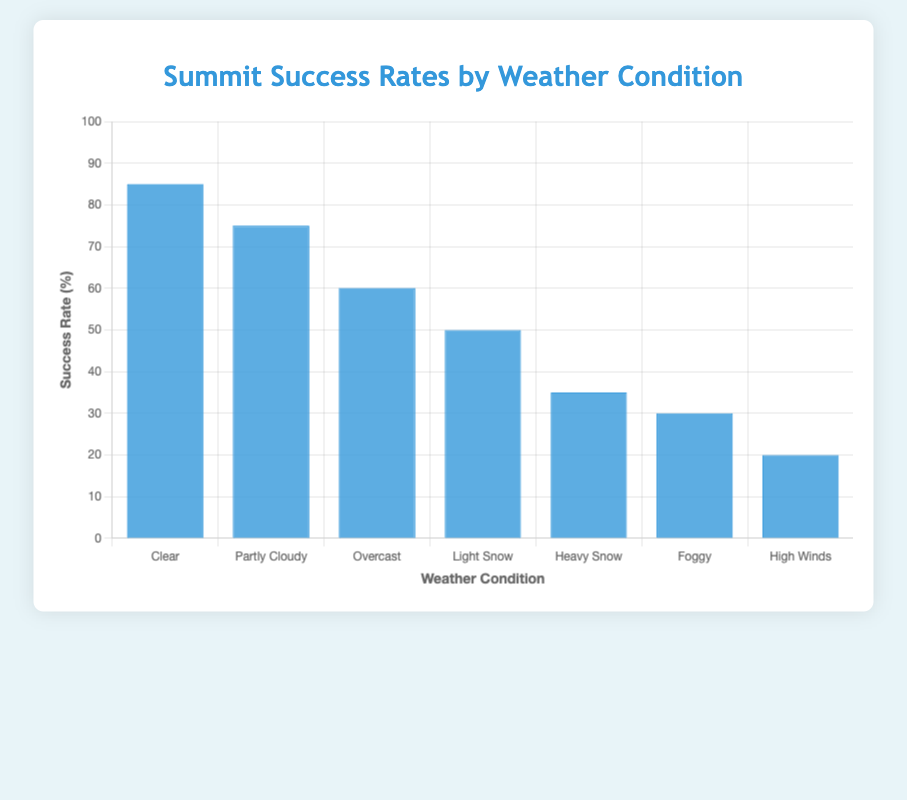What weather condition has the highest summit success rate? The bar for "Clear" weather condition is the tallest, indicating the highest success rate compared to the other weather conditions.
Answer: Clear Which weather condition has a summit success rate higher than "Light Snow" and lower than "Clear"? The "Partly Cloudy" weather condition has a higher success rate than "Light Snow" but lower than "Clear," with success rates of 75% and 50% respectively.
Answer: Partly Cloudy Compare the summit success rates between "Heavy Snow" and "Foggy." Which is higher? The bar for "Heavy Snow" is slightly higher than the bar for "Foggy," indicating that "Heavy Snow" has a higher success rate. "Heavy Snow" is 35% and "Foggy" is 30%.
Answer: Heavy Snow What is the combined success rate for "Clear" and "Partly Cloudy" weather conditions? Summing the success rates of "Clear" (85%) and "Partly Cloudy" (75%) results in 85 + 75 = 160.
Answer: 160 Find the difference in success rate between "High Winds" and "Partly Cloudy." The success rate for "Partly Cloudy" is 75%, and for "High Winds" it is 20%. The difference is 75 - 20 = 55.
Answer: 55 Which weather condition has the smallest success rate, and what is it? The shortest bar represents the "High Winds" weather condition, indicating it has the smallest success rate.
Answer: High Winds Arrange the weather conditions in descending order of summit success rates. The order from the tallest to the shortest bars is: Clear, Partly Cloudy, Overcast, Light Snow, Heavy Snow, Foggy, High Winds.
Answer: Clear, Partly Cloudy, Overcast, Light Snow, Heavy Snow, Foggy, High Winds What is the average success rate of all summit attempts? Summing all the success rates: 85 + 75 + 60 + 50 + 35 + 30 + 20 = 355. Dividing by the number of conditions (7): 355 / 7 = 50.7.
Answer: 50.7 State the success rate for "Overcast" weather condition and compare it to the "Light Snow" condition. "Overcast" has a success rate of 60%, while "Light Snow" has 50%. So, "Overcast" is higher.
Answer: 60%, Overcast higher 